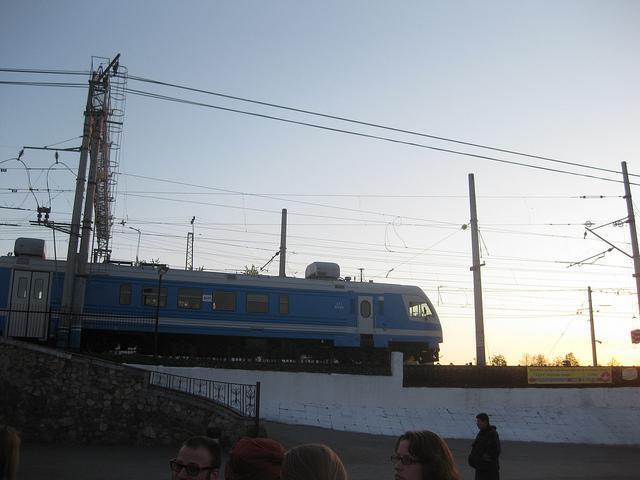How many people appear in this photo?
Give a very brief answer. 5. How many people are visible?
Give a very brief answer. 2. 